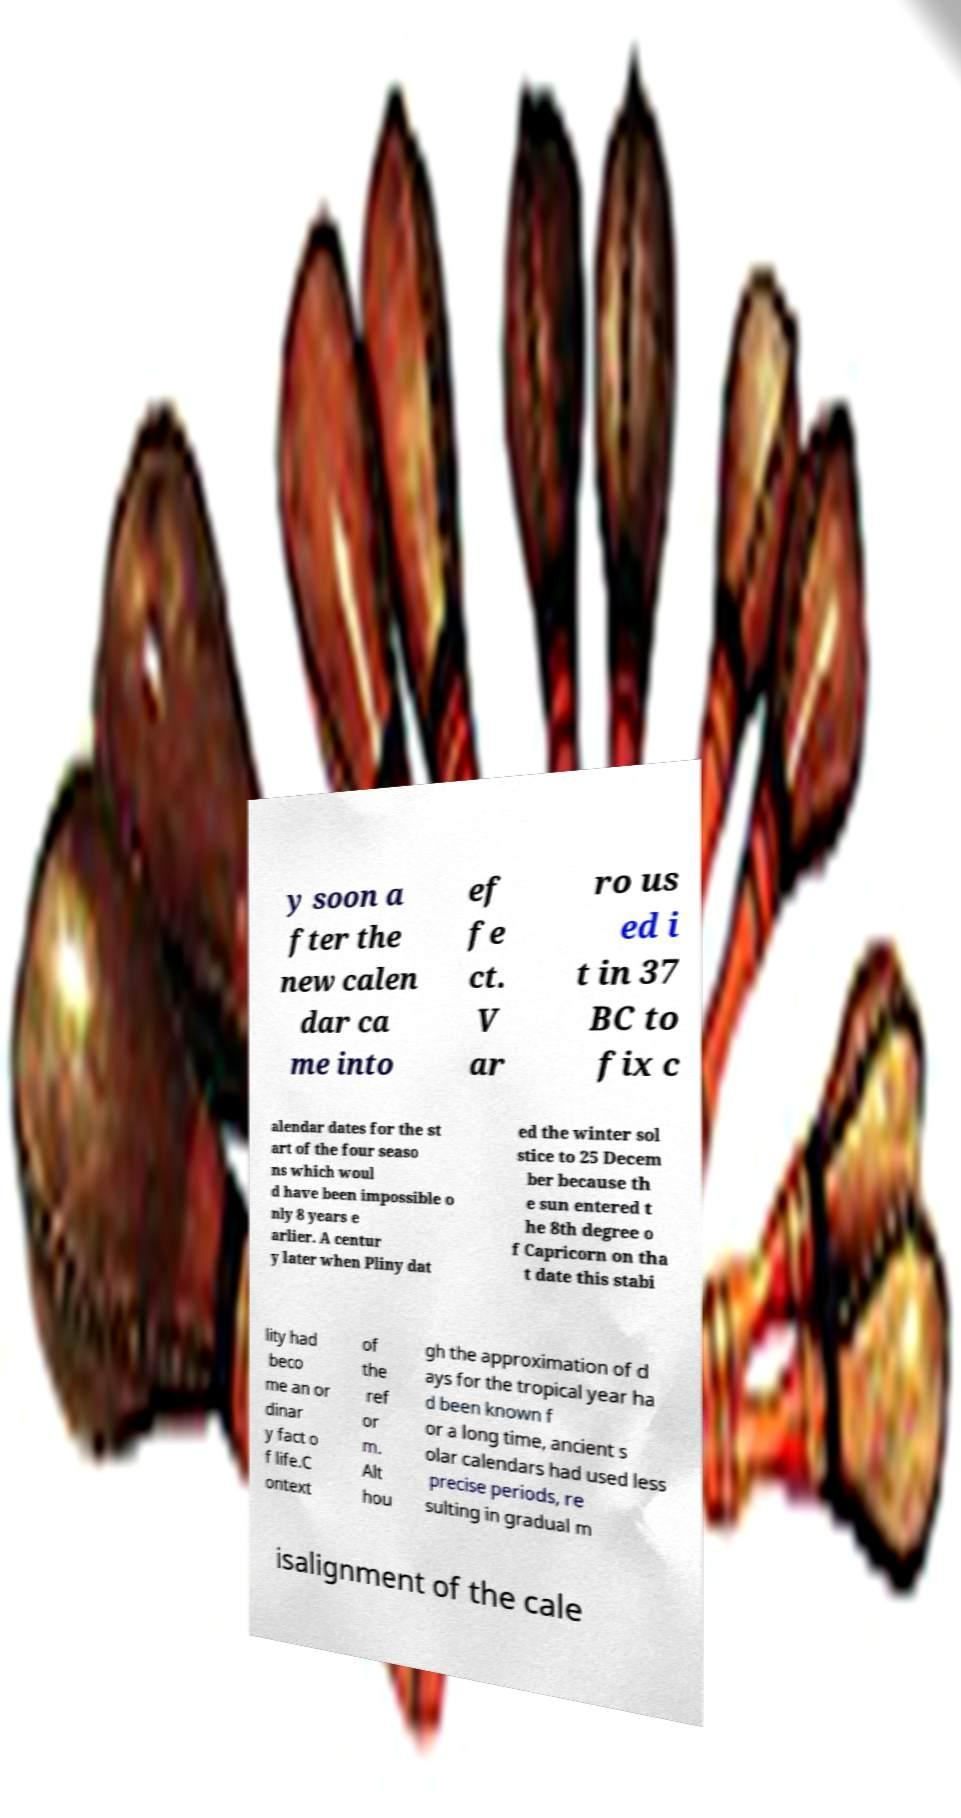I need the written content from this picture converted into text. Can you do that? y soon a fter the new calen dar ca me into ef fe ct. V ar ro us ed i t in 37 BC to fix c alendar dates for the st art of the four seaso ns which woul d have been impossible o nly 8 years e arlier. A centur y later when Pliny dat ed the winter sol stice to 25 Decem ber because th e sun entered t he 8th degree o f Capricorn on tha t date this stabi lity had beco me an or dinar y fact o f life.C ontext of the ref or m. Alt hou gh the approximation of d ays for the tropical year ha d been known f or a long time, ancient s olar calendars had used less precise periods, re sulting in gradual m isalignment of the cale 